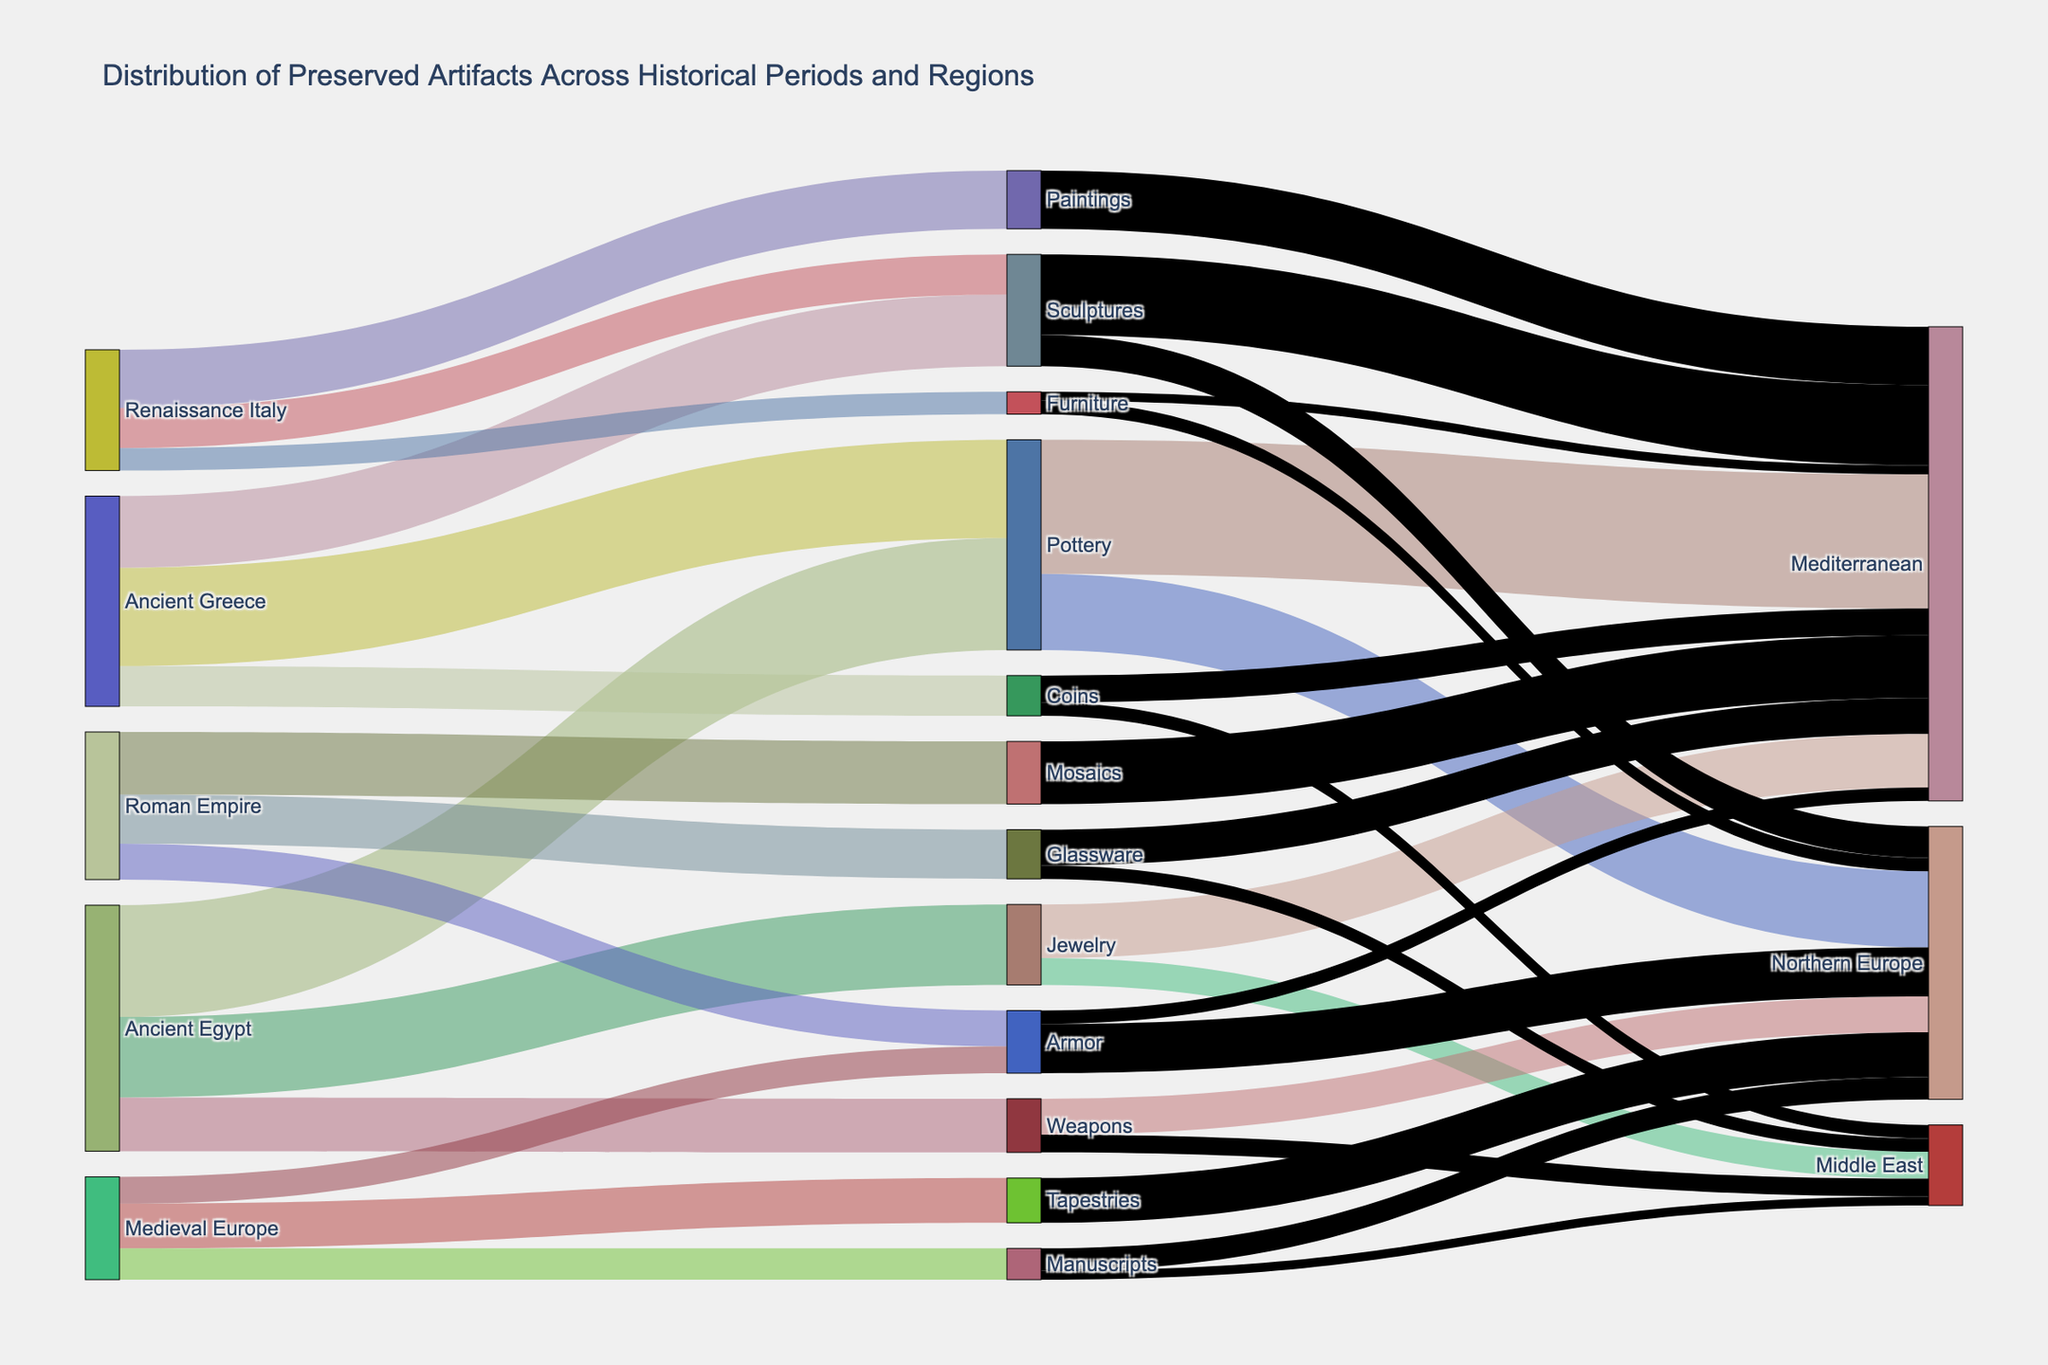Which historical period has the highest number of preserved artifacts in the museum collection? To find the historical period with the highest number of preserved artifacts, observe the source side of the Sankey diagram and locate the node with the largest total sum of values that flow out from it. By examining the values, Ancient Egypt has 2500 (Pottery) + 1800 (Jewelry) + 1200 (Weapons) = 5500 artifacts, Ancient Greece has 2200 (Pottery) + 1600 (Sculptures) + 900 (Coins) = 4700 artifacts, Roman Empire has 1400 (Mosaics) + 1100 (Glassware) + 800 (Armor) = 3300 artifacts, and so on. Thus, Ancient Egypt has the highest total number.
Answer: Ancient Egypt How many regions have preserved pottery from Ancient Egypt? Find the 'Pottery' node and count how many links flow from Pottery to different geographical regions. In the diagram, Pottery links to 'Mediterranean' and 'Northern Europe'.
Answer: 2 Which artifact type has the highest number of items preserved in the Mediterranean region? Trace the links leading to 'Mediterranean' and compare the values. Pottery has 3000, Jewelry has 1200, Sculptures has 1800, Mosaics has 1400, Glassware has 800, Coins has 600, Armor has 300, Paintings has 1300, and Furniture has 200. The highest value among these is for Pottery (3000).
Answer: Pottery Compare the sum of preserved artifacts from Medieval Europe and Renaissance Italy. Which has more? Calculate the total values for Medieval Europe (1000 Tapestries + 700 Manuscripts + 600 Armor = 2300) and Renaissance Italy (1300 Paintings + 900 Sculptures + 500 Furniture = 2700). Renaissance Italy has 2700 artifacts whereas Medieval Europe has 2300. Hence, Renaissance Italy has more artifacts.
Answer: Renaissance Italy What is the total number of sculptures preserved from Ancient Greece and Renaissance Italy? Add the number of sculptures from both periods (Ancient Greece has 1600 Sculptures, and Renaissance Italy has 900 Sculptures). The total is 1600 + 900 = 2500.
Answer: 2500 How many geographical regions have preserved armor from the Roman Empire? Find the 'Armor' node linked to the Roman Empire and the geographical nodes connected to it. Armor links to 'Northern Europe' (1100) and 'Mediterranean' (300). Count these regions.
Answer: 2 Which type of artifact has more items preserved in the Northern Europe region: Manuscripts or Tapestries? Compare the values for Manuscripts (500) and Tapestries (1000) linking to Northern Europe. Tapestries have more items preserved.
Answer: Tapestries From the artifacts preserved in the Middle East, which historical period contributed the most? Trace the links ending in Middle East and sum the artifact types from different periods. Jewelry from Ancient Egypt has 600, Weapons from Ancient Egypt has 400, Coins from Ancient Greece has 300, Glassware from Roman Empire has 300, and Manuscripts from Medieval Europe has 200. The maximum contribution is by Jewelry from Ancient Egypt (600).
Answer: Ancient Egypt What is the total number of artifacts preserved in Northern Europe? Add all values for artifacts linked to Northern Europe: Pottery (1700), Weapons (800), Sculptures (700), Armor (1100), Tapestries (1000), Manuscripts (500), and Furniture (300). The total is 1700 + 800 + 700 + 1100 + 1000 + 500 + 300 = 6100.
Answer: 6100 